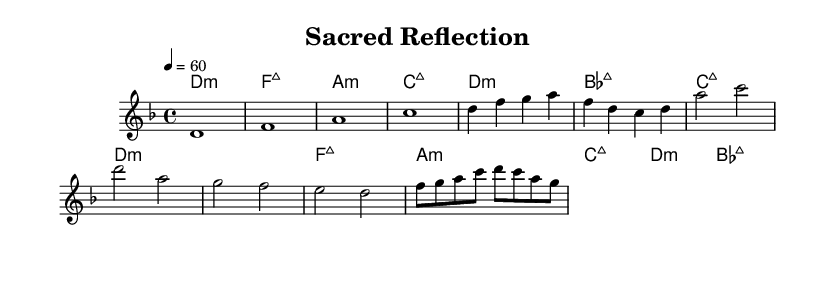What is the key signature of this music? The key signature shows two flats, indicating that the piece is in the key of D minor.
Answer: D minor What is the time signature of this music? The time signature is displayed at the beginning of the score, which indicates four beats per measure, known as 4/4 time.
Answer: 4/4 What is the tempo marking for this piece? The tempo marking is indicated by the note value and beats per minute. Here it is marked as quarter note equals 60, meaning one quarter note gets a beat and there are 60 beats in a minute.
Answer: 60 What is the main harmonic progression in the verse? The verse features a series of chords in the sequence of D minor, B flat major, C major, and D minor, creating a reflective mood.
Answer: D minor, B flat major, C major, D minor How many bars are there in the chorus? By counting the notation in the score, it is evident that the chorus consists of four measures or bars.
Answer: 4 What is the primary emotion conveyed by the piece based on its tempo and key? The combination of the slow tempo, minor key, and ambient qualities typically conveys a mood of contemplation and introspection, ideal for personal reflection or prayer.
Answer: Contemplation 